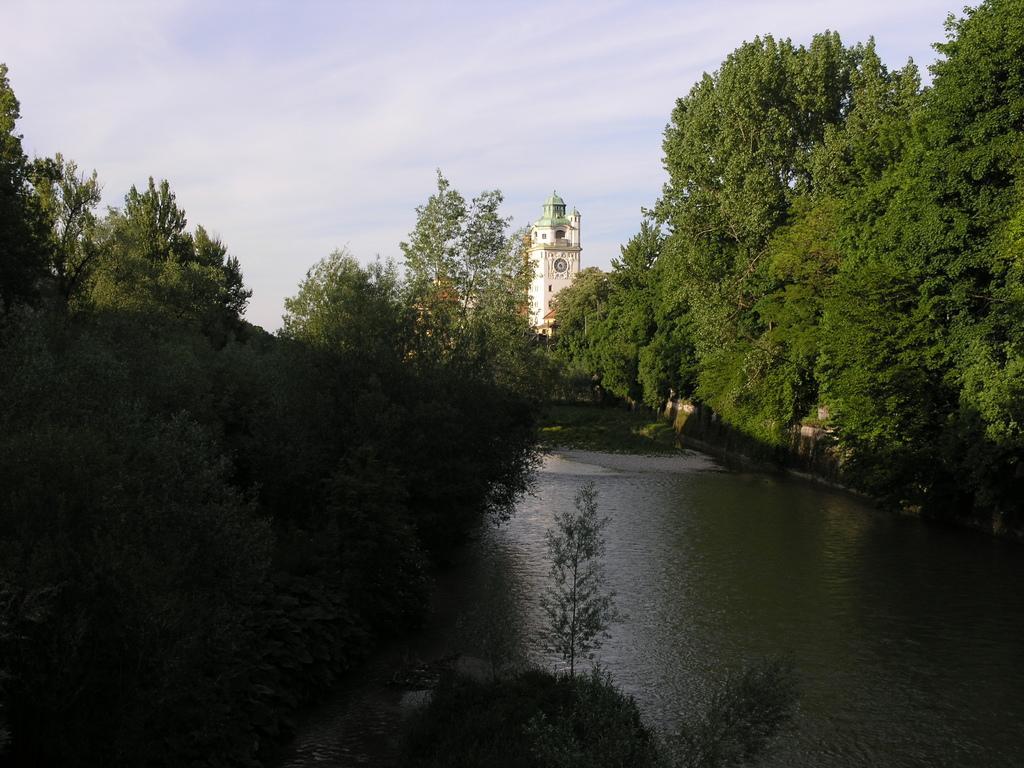Could you give a brief overview of what you see in this image? In this images at the bottom there is a river, and there are some plants. And on the right side and left side of the image there are some trees, and in the background there is a tower. At the top of the image there is sky. 